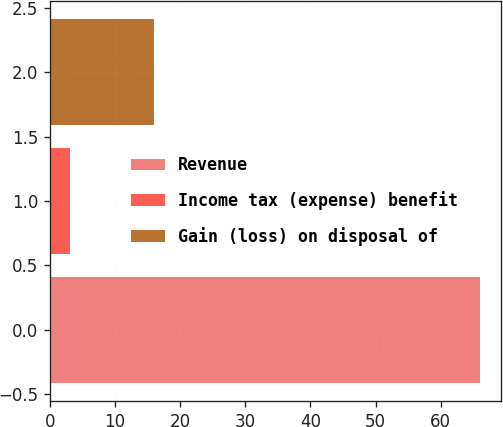<chart> <loc_0><loc_0><loc_500><loc_500><bar_chart><fcel>Revenue<fcel>Income tax (expense) benefit<fcel>Gain (loss) on disposal of<nl><fcel>66<fcel>3<fcel>16<nl></chart> 